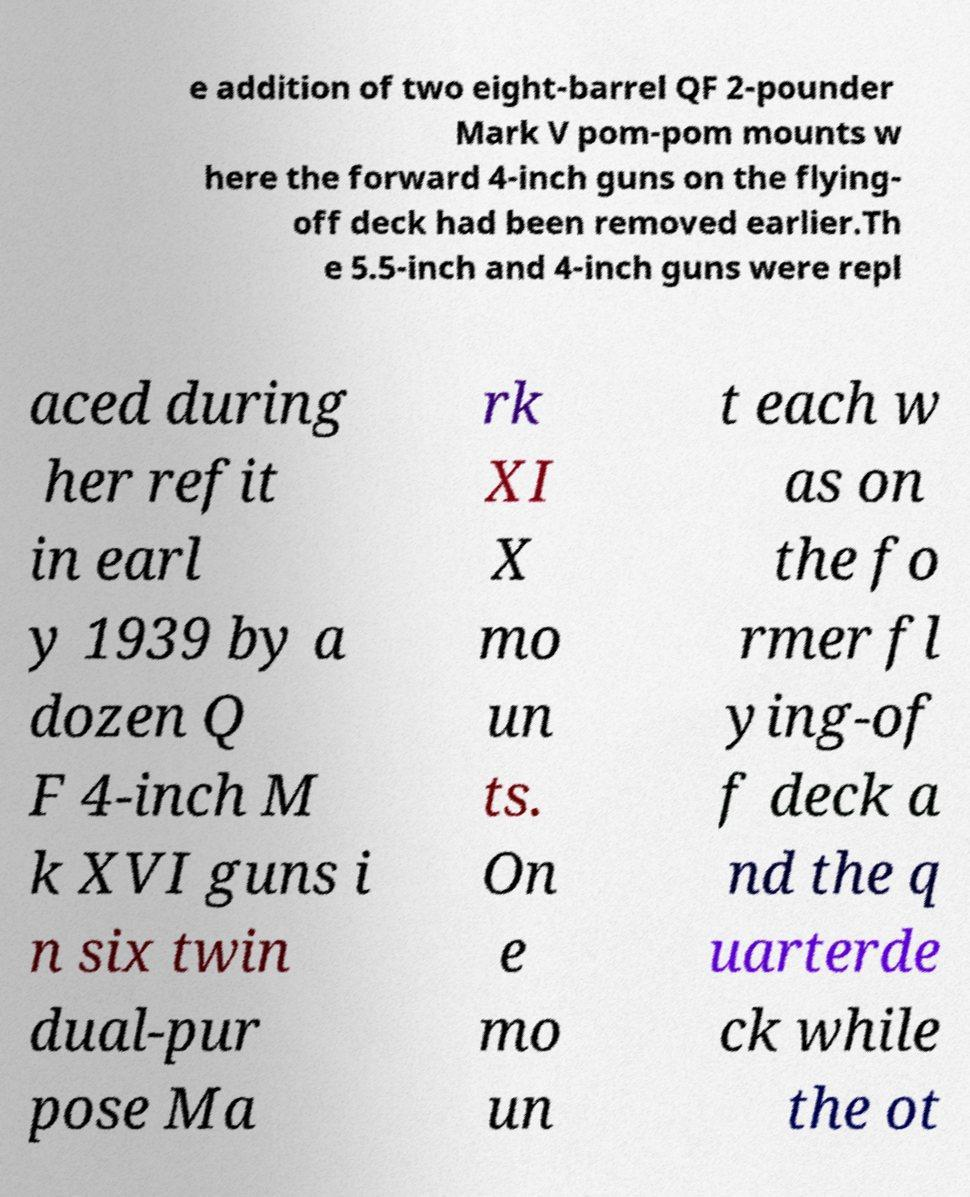Can you read and provide the text displayed in the image?This photo seems to have some interesting text. Can you extract and type it out for me? e addition of two eight-barrel QF 2-pounder Mark V pom-pom mounts w here the forward 4-inch guns on the flying- off deck had been removed earlier.Th e 5.5-inch and 4-inch guns were repl aced during her refit in earl y 1939 by a dozen Q F 4-inch M k XVI guns i n six twin dual-pur pose Ma rk XI X mo un ts. On e mo un t each w as on the fo rmer fl ying-of f deck a nd the q uarterde ck while the ot 